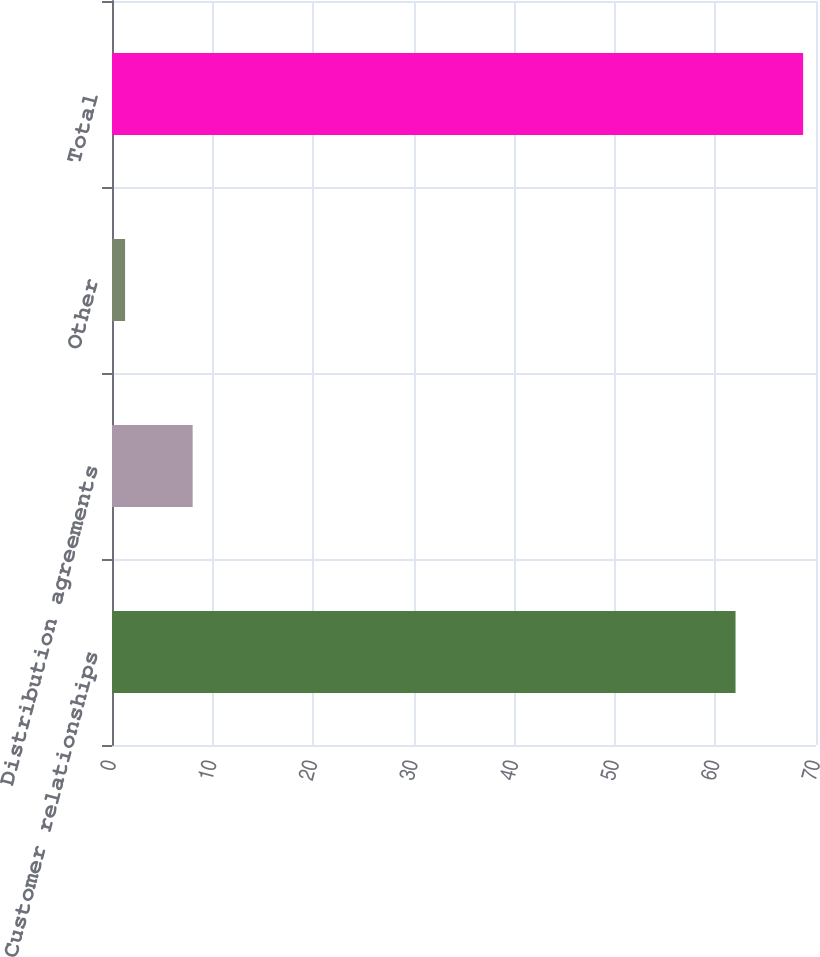<chart> <loc_0><loc_0><loc_500><loc_500><bar_chart><fcel>Customer relationships<fcel>Distribution agreements<fcel>Other<fcel>Total<nl><fcel>62<fcel>8.02<fcel>1.3<fcel>68.72<nl></chart> 